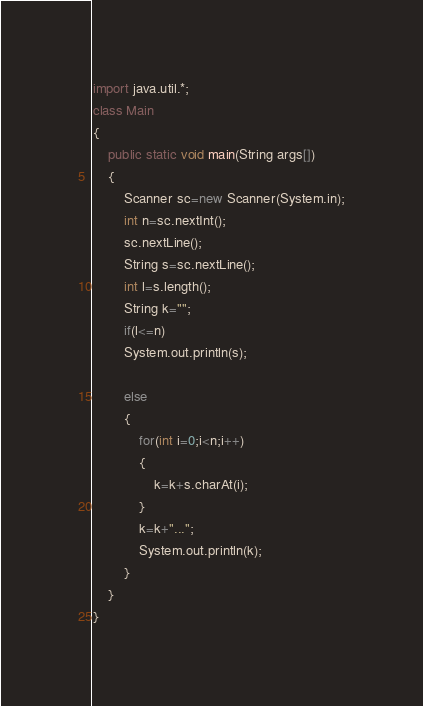Convert code to text. <code><loc_0><loc_0><loc_500><loc_500><_Java_>import java.util.*;
class Main
{
    public static void main(String args[])
    {
        Scanner sc=new Scanner(System.in);
        int n=sc.nextInt();
        sc.nextLine();
        String s=sc.nextLine();
        int l=s.length();
        String k="";
        if(l<=n)
        System.out.println(s);
        
        else
        {
            for(int i=0;i<n;i++)
            {
                k=k+s.charAt(i);
            }
            k=k+"...";
            System.out.println(k);
        }
    }
}
</code> 